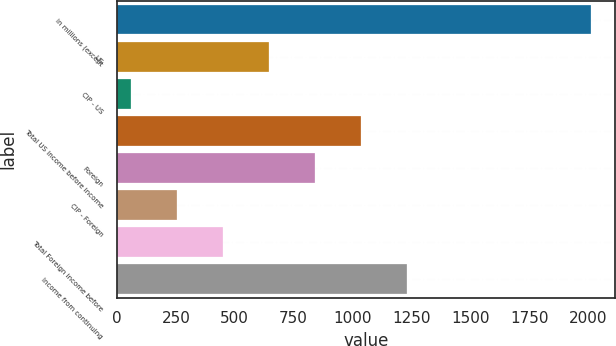Convert chart. <chart><loc_0><loc_0><loc_500><loc_500><bar_chart><fcel>in millions (except<fcel>US<fcel>CIP - US<fcel>Total US income before income<fcel>Foreign<fcel>CIP - Foreign<fcel>Total Foreign income before<fcel>Income from continuing<nl><fcel>2012<fcel>645.39<fcel>59.7<fcel>1035.85<fcel>840.62<fcel>254.93<fcel>450.16<fcel>1231.08<nl></chart> 